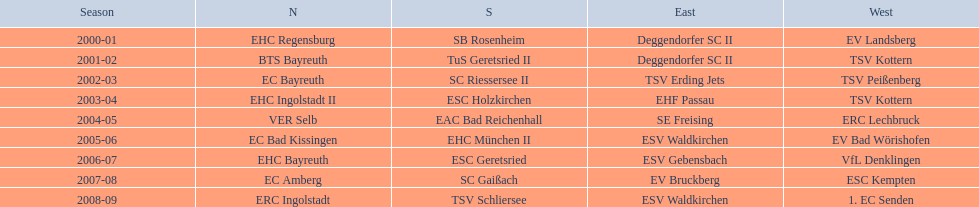Which teams have won in the bavarian ice hockey leagues between 2000 and 2009? EHC Regensburg, SB Rosenheim, Deggendorfer SC II, EV Landsberg, BTS Bayreuth, TuS Geretsried II, TSV Kottern, EC Bayreuth, SC Riessersee II, TSV Erding Jets, TSV Peißenberg, EHC Ingolstadt II, ESC Holzkirchen, EHF Passau, TSV Kottern, VER Selb, EAC Bad Reichenhall, SE Freising, ERC Lechbruck, EC Bad Kissingen, EHC München II, ESV Waldkirchen, EV Bad Wörishofen, EHC Bayreuth, ESC Geretsried, ESV Gebensbach, VfL Denklingen, EC Amberg, SC Gaißach, EV Bruckberg, ESC Kempten, ERC Ingolstadt, TSV Schliersee, ESV Waldkirchen, 1. EC Senden. Could you parse the entire table as a dict? {'header': ['Season', 'N', 'S', 'East', 'West'], 'rows': [['2000-01', 'EHC Regensburg', 'SB Rosenheim', 'Deggendorfer SC II', 'EV Landsberg'], ['2001-02', 'BTS Bayreuth', 'TuS Geretsried II', 'Deggendorfer SC II', 'TSV Kottern'], ['2002-03', 'EC Bayreuth', 'SC Riessersee II', 'TSV Erding Jets', 'TSV Peißenberg'], ['2003-04', 'EHC Ingolstadt II', 'ESC Holzkirchen', 'EHF Passau', 'TSV Kottern'], ['2004-05', 'VER Selb', 'EAC Bad Reichenhall', 'SE Freising', 'ERC Lechbruck'], ['2005-06', 'EC Bad Kissingen', 'EHC München II', 'ESV Waldkirchen', 'EV Bad Wörishofen'], ['2006-07', 'EHC Bayreuth', 'ESC Geretsried', 'ESV Gebensbach', 'VfL Denklingen'], ['2007-08', 'EC Amberg', 'SC Gaißach', 'EV Bruckberg', 'ESC Kempten'], ['2008-09', 'ERC Ingolstadt', 'TSV Schliersee', 'ESV Waldkirchen', '1. EC Senden']]} Which of these winning teams have won the north? EHC Regensburg, BTS Bayreuth, EC Bayreuth, EHC Ingolstadt II, VER Selb, EC Bad Kissingen, EHC Bayreuth, EC Amberg, ERC Ingolstadt. Which of the teams that won the north won in the 2000/2001 season? EHC Regensburg. 